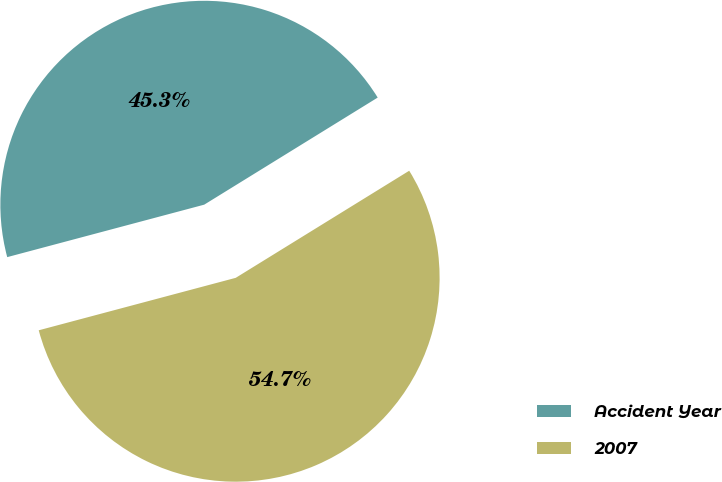Convert chart to OTSL. <chart><loc_0><loc_0><loc_500><loc_500><pie_chart><fcel>Accident Year<fcel>2007<nl><fcel>45.34%<fcel>54.66%<nl></chart> 